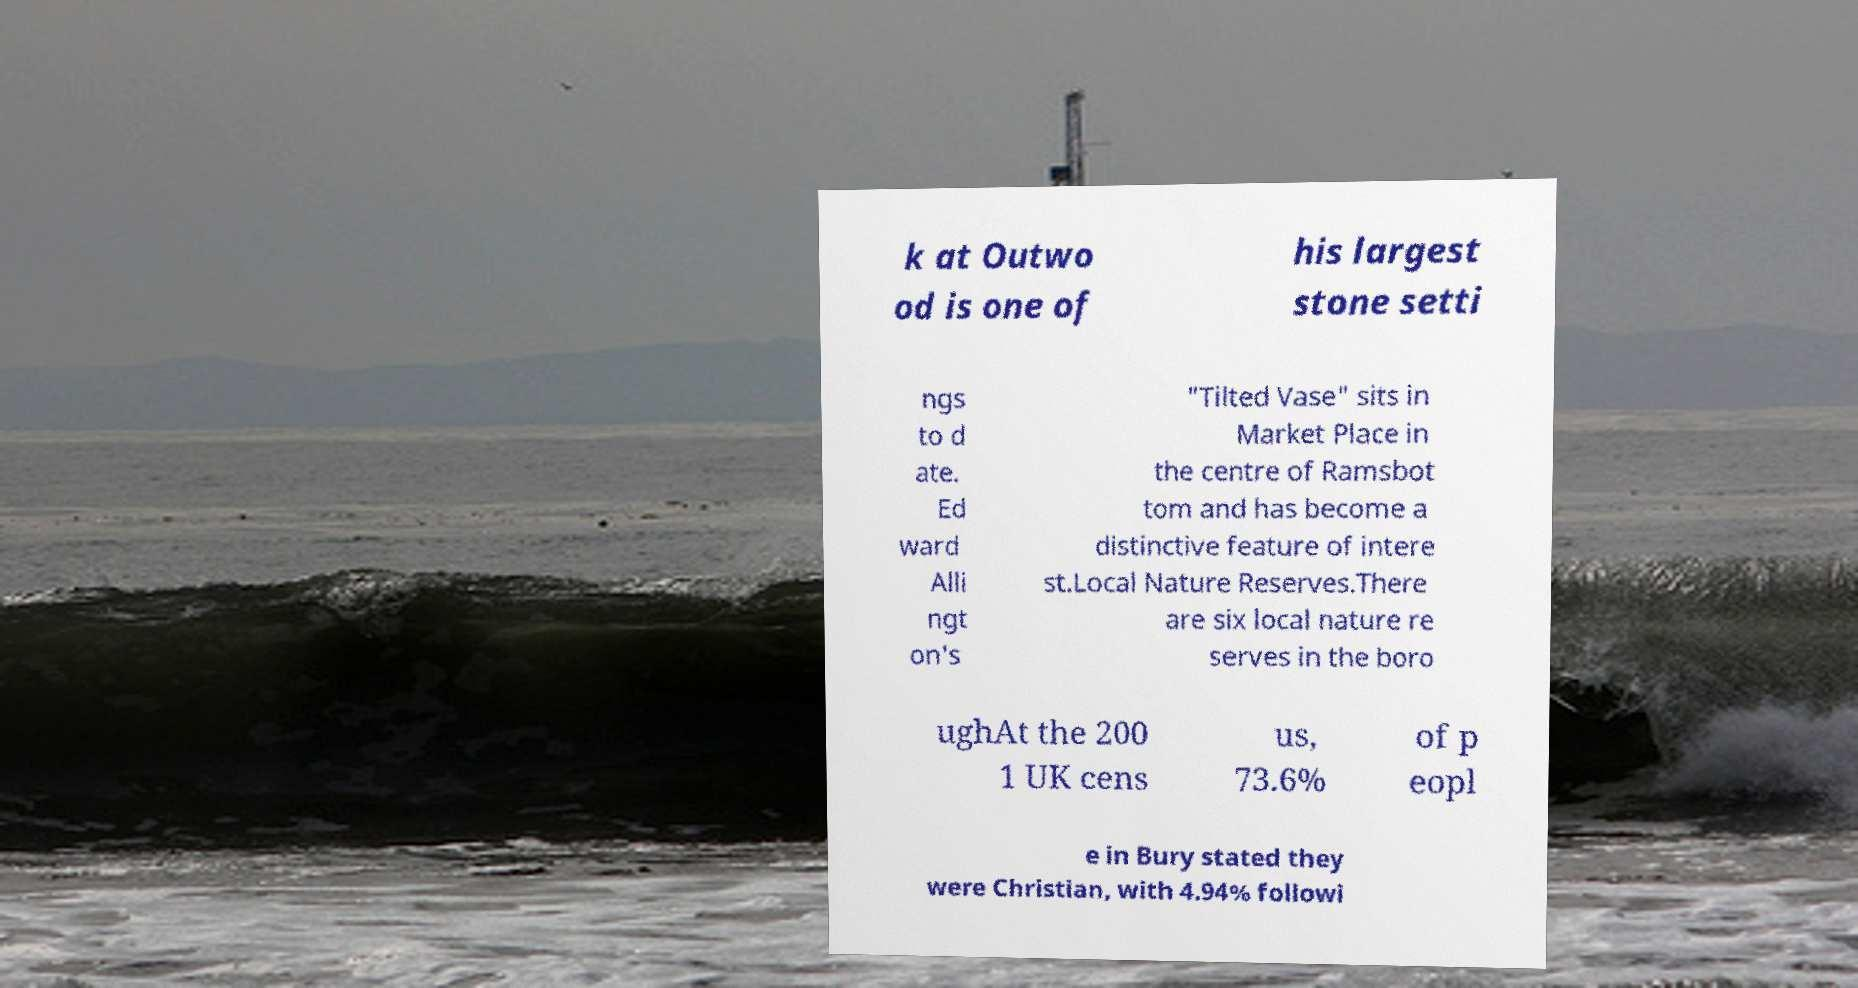Can you accurately transcribe the text from the provided image for me? k at Outwo od is one of his largest stone setti ngs to d ate. Ed ward Alli ngt on's "Tilted Vase" sits in Market Place in the centre of Ramsbot tom and has become a distinctive feature of intere st.Local Nature Reserves.There are six local nature re serves in the boro ughAt the 200 1 UK cens us, 73.6% of p eopl e in Bury stated they were Christian, with 4.94% followi 